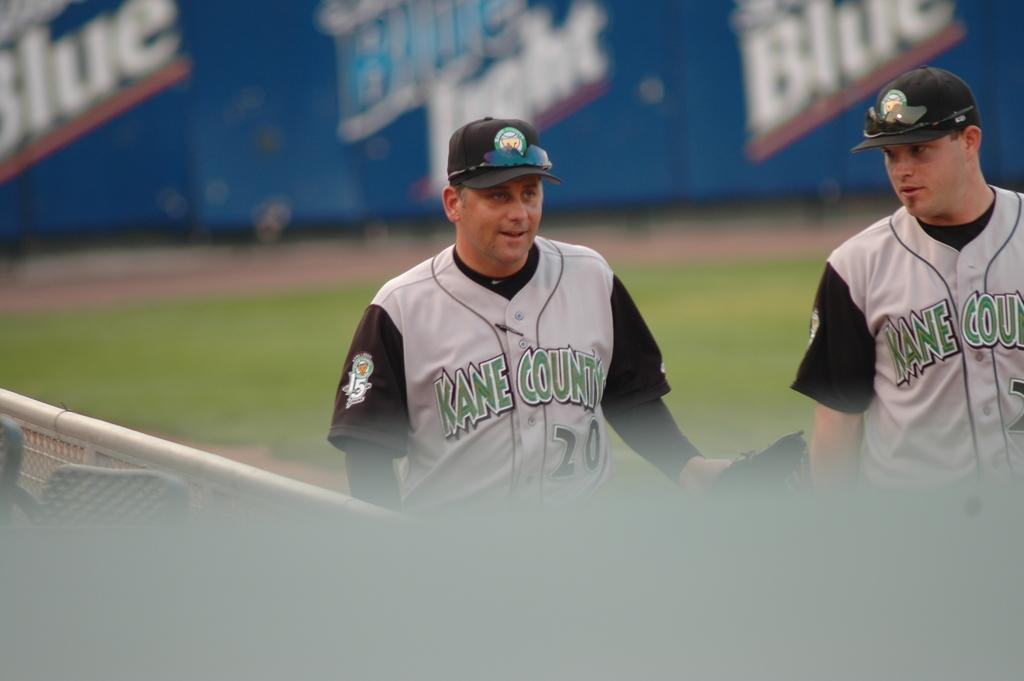<image>
Write a terse but informative summary of the picture. The two players shown are from Kane County. 